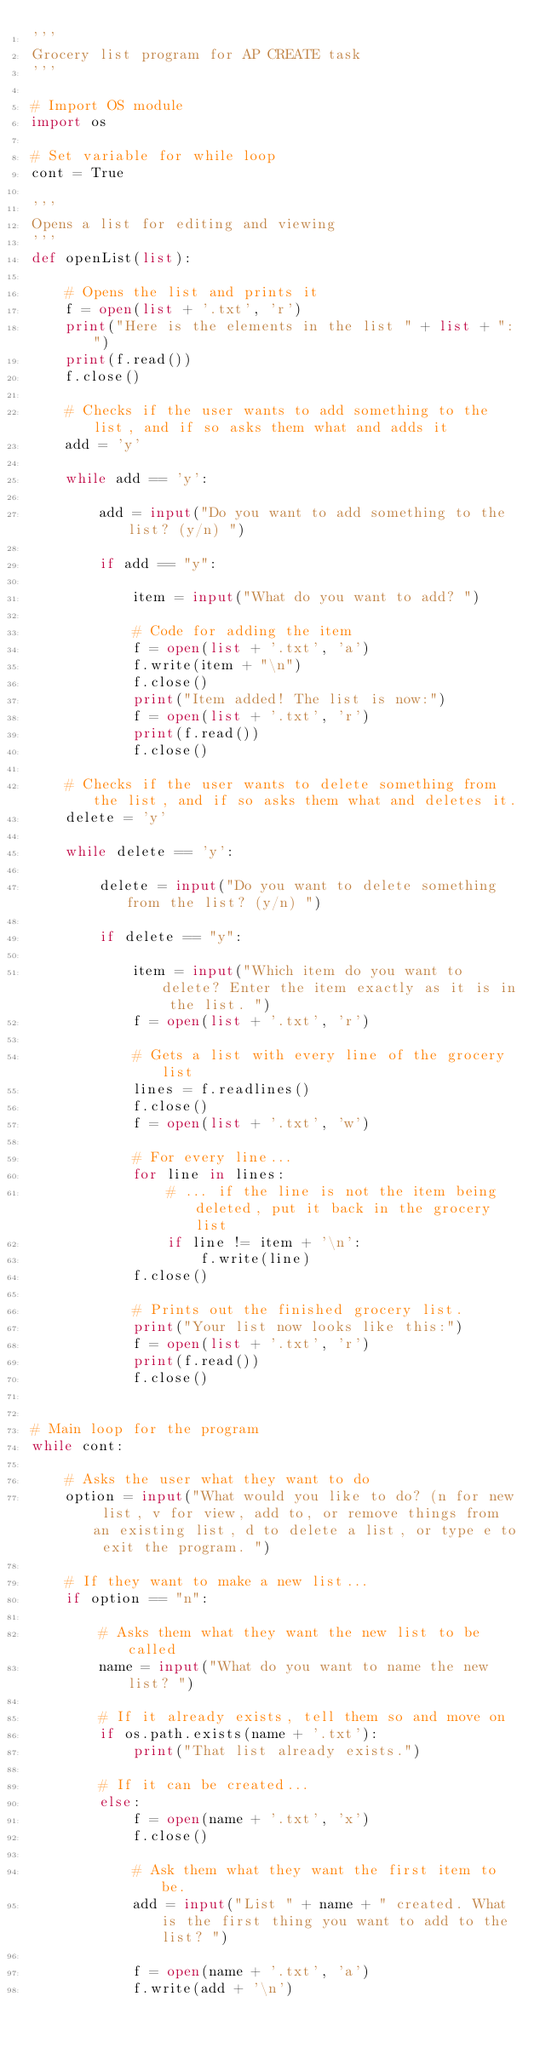<code> <loc_0><loc_0><loc_500><loc_500><_Python_>'''
Grocery list program for AP CREATE task
'''

# Import OS module
import os

# Set variable for while loop
cont = True

'''
Opens a list for editing and viewing
'''
def openList(list):

    # Opens the list and prints it
    f = open(list + '.txt', 'r')
    print("Here is the elements in the list " + list + ":")
    print(f.read())
    f.close()

    # Checks if the user wants to add something to the list, and if so asks them what and adds it
    add = 'y'

    while add == 'y':

        add = input("Do you want to add something to the list? (y/n) ")

        if add == "y":

            item = input("What do you want to add? ")

            # Code for adding the item
            f = open(list + '.txt', 'a')
            f.write(item + "\n")
            f.close()
            print("Item added! The list is now:")
            f = open(list + '.txt', 'r')
            print(f.read())
            f.close()
    
    # Checks if the user wants to delete something from the list, and if so asks them what and deletes it.
    delete = 'y'

    while delete == 'y':

        delete = input("Do you want to delete something from the list? (y/n) ")

        if delete == "y":

            item = input("Which item do you want to delete? Enter the item exactly as it is in the list. ")
            f = open(list + '.txt', 'r')

            # Gets a list with every line of the grocery list
            lines = f.readlines()
            f.close()
            f = open(list + '.txt', 'w')

            # For every line...
            for line in lines:
                # ... if the line is not the item being deleted, put it back in the grocery list
                if line != item + '\n':
                    f.write(line)
            f.close()

            # Prints out the finished grocery list.
            print("Your list now looks like this:")
            f = open(list + '.txt', 'r')
            print(f.read())
            f.close()


# Main loop for the program
while cont:

    # Asks the user what they want to do
    option = input("What would you like to do? (n for new list, v for view, add to, or remove things from an existing list, d to delete a list, or type e to exit the program. ")

    # If they want to make a new list...
    if option == "n":

        # Asks them what they want the new list to be called
        name = input("What do you want to name the new list? ")

        # If it already exists, tell them so and move on
        if os.path.exists(name + '.txt'):
            print("That list already exists.")

        # If it can be created...
        else:
            f = open(name + '.txt', 'x')
            f.close()

            # Ask them what they want the first item to be.
            add = input("List " + name + " created. What is the first thing you want to add to the list? ")

            f = open(name + '.txt', 'a')
            f.write(add + '\n')</code> 